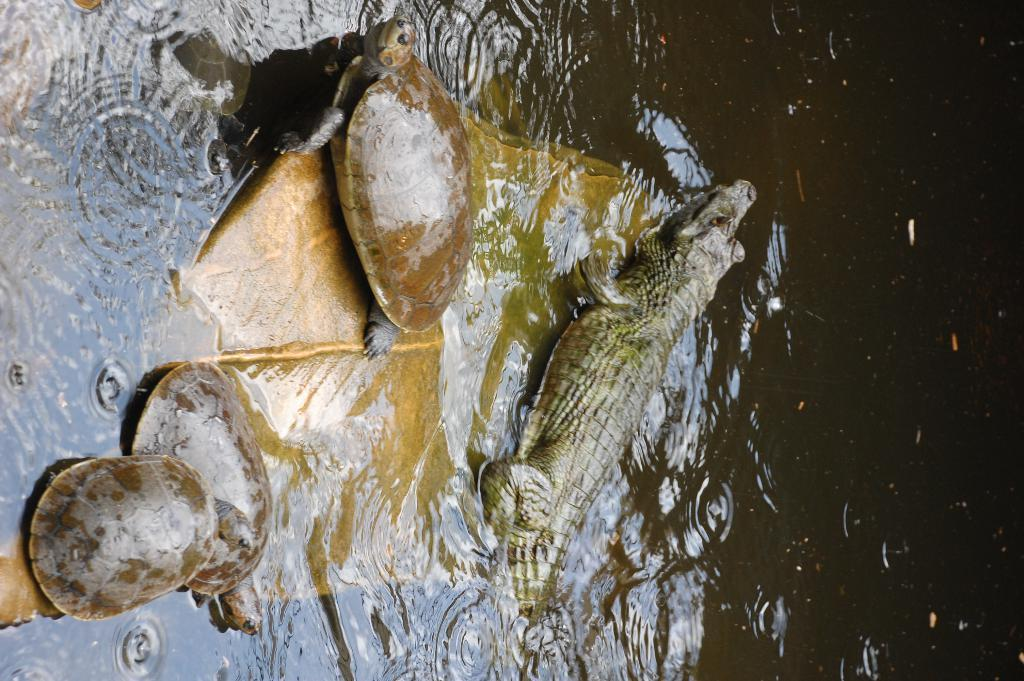What is the primary element present in the image? There is water in the image. What can be found in the water? There is a stone in the water. What creatures are on the stone? There are turtles and a crocodile in holding its position on the stone? Can you describe the stone's location in the image? The stone is in the water. How many fish are swimming around the jellyfish in the image? There are no fish or jellyfish present in the image. What type of creature is rubbing its back on the stone in the image? There is no creature rubbing its back on the stone in the image. 